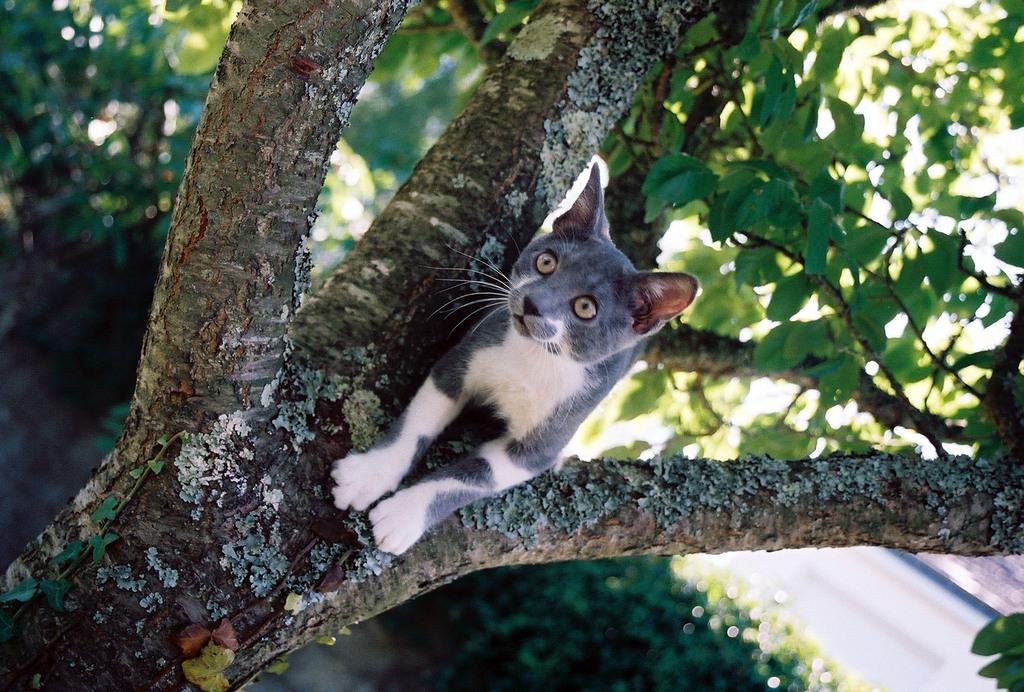Please provide a concise description of this image. In this picture we can see a cat on the tree and behind the trees there are plants and a path. 